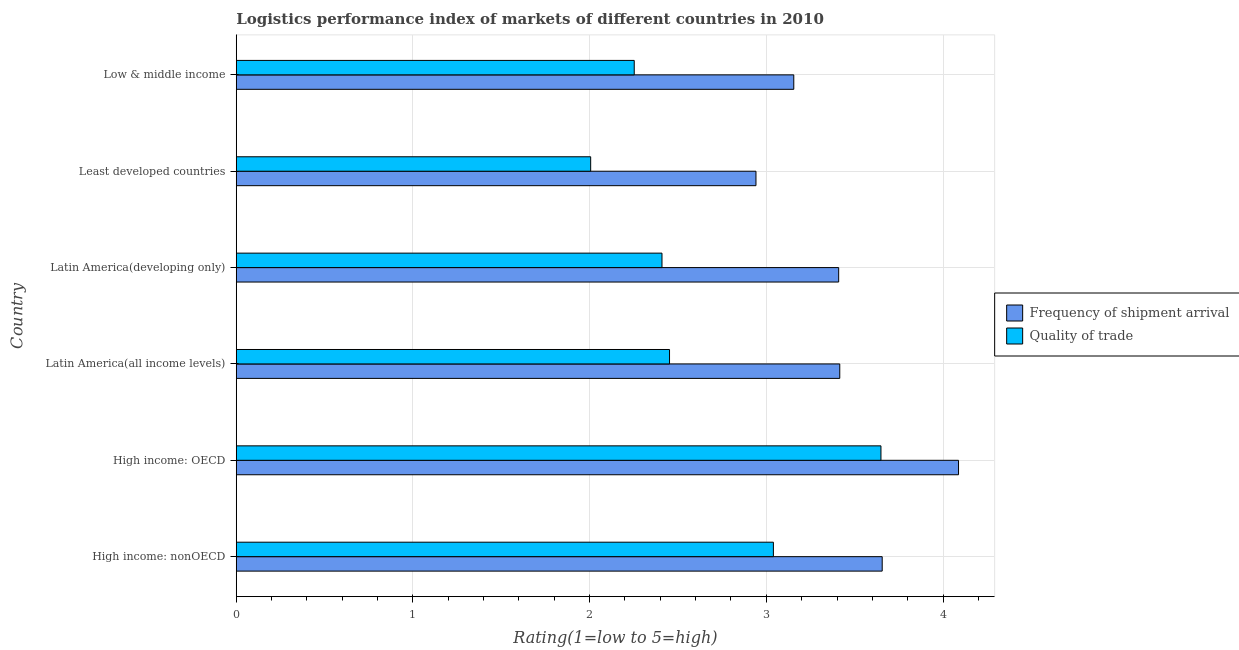How many different coloured bars are there?
Offer a very short reply. 2. How many groups of bars are there?
Your answer should be very brief. 6. What is the label of the 2nd group of bars from the top?
Provide a succinct answer. Least developed countries. In how many cases, is the number of bars for a given country not equal to the number of legend labels?
Keep it short and to the point. 0. What is the lpi quality of trade in Latin America(all income levels)?
Give a very brief answer. 2.45. Across all countries, what is the maximum lpi quality of trade?
Make the answer very short. 3.65. Across all countries, what is the minimum lpi quality of trade?
Provide a succinct answer. 2.01. In which country was the lpi quality of trade maximum?
Ensure brevity in your answer.  High income: OECD. In which country was the lpi quality of trade minimum?
Offer a terse response. Least developed countries. What is the total lpi quality of trade in the graph?
Keep it short and to the point. 15.81. What is the difference between the lpi quality of trade in High income: nonOECD and that in Latin America(all income levels)?
Make the answer very short. 0.59. What is the difference between the lpi quality of trade in Low & middle income and the lpi of frequency of shipment arrival in Latin America(all income levels)?
Your response must be concise. -1.16. What is the average lpi of frequency of shipment arrival per country?
Your answer should be compact. 3.44. What is the difference between the lpi of frequency of shipment arrival and lpi quality of trade in High income: nonOECD?
Keep it short and to the point. 0.62. What is the ratio of the lpi quality of trade in High income: nonOECD to that in Least developed countries?
Your answer should be very brief. 1.52. Is the difference between the lpi of frequency of shipment arrival in Latin America(all income levels) and Low & middle income greater than the difference between the lpi quality of trade in Latin America(all income levels) and Low & middle income?
Provide a short and direct response. Yes. What is the difference between the highest and the second highest lpi of frequency of shipment arrival?
Give a very brief answer. 0.43. What is the difference between the highest and the lowest lpi of frequency of shipment arrival?
Your response must be concise. 1.15. In how many countries, is the lpi quality of trade greater than the average lpi quality of trade taken over all countries?
Your response must be concise. 2. What does the 1st bar from the top in Latin America(developing only) represents?
Ensure brevity in your answer.  Quality of trade. What does the 1st bar from the bottom in Low & middle income represents?
Your response must be concise. Frequency of shipment arrival. How many countries are there in the graph?
Keep it short and to the point. 6. What is the difference between two consecutive major ticks on the X-axis?
Your answer should be very brief. 1. Are the values on the major ticks of X-axis written in scientific E-notation?
Your answer should be very brief. No. Does the graph contain any zero values?
Give a very brief answer. No. Where does the legend appear in the graph?
Your answer should be compact. Center right. How many legend labels are there?
Your answer should be compact. 2. How are the legend labels stacked?
Your answer should be compact. Vertical. What is the title of the graph?
Provide a succinct answer. Logistics performance index of markets of different countries in 2010. Does "Taxes on exports" appear as one of the legend labels in the graph?
Offer a terse response. No. What is the label or title of the X-axis?
Provide a succinct answer. Rating(1=low to 5=high). What is the label or title of the Y-axis?
Provide a succinct answer. Country. What is the Rating(1=low to 5=high) of Frequency of shipment arrival in High income: nonOECD?
Give a very brief answer. 3.66. What is the Rating(1=low to 5=high) of Quality of trade in High income: nonOECD?
Offer a terse response. 3.04. What is the Rating(1=low to 5=high) in Frequency of shipment arrival in High income: OECD?
Your answer should be compact. 4.09. What is the Rating(1=low to 5=high) of Quality of trade in High income: OECD?
Offer a terse response. 3.65. What is the Rating(1=low to 5=high) in Frequency of shipment arrival in Latin America(all income levels)?
Offer a terse response. 3.42. What is the Rating(1=low to 5=high) in Quality of trade in Latin America(all income levels)?
Make the answer very short. 2.45. What is the Rating(1=low to 5=high) in Frequency of shipment arrival in Latin America(developing only)?
Make the answer very short. 3.41. What is the Rating(1=low to 5=high) of Quality of trade in Latin America(developing only)?
Offer a very short reply. 2.41. What is the Rating(1=low to 5=high) of Frequency of shipment arrival in Least developed countries?
Your answer should be very brief. 2.94. What is the Rating(1=low to 5=high) in Quality of trade in Least developed countries?
Keep it short and to the point. 2.01. What is the Rating(1=low to 5=high) in Frequency of shipment arrival in Low & middle income?
Provide a succinct answer. 3.16. What is the Rating(1=low to 5=high) in Quality of trade in Low & middle income?
Offer a very short reply. 2.25. Across all countries, what is the maximum Rating(1=low to 5=high) in Frequency of shipment arrival?
Make the answer very short. 4.09. Across all countries, what is the maximum Rating(1=low to 5=high) of Quality of trade?
Offer a terse response. 3.65. Across all countries, what is the minimum Rating(1=low to 5=high) of Frequency of shipment arrival?
Give a very brief answer. 2.94. Across all countries, what is the minimum Rating(1=low to 5=high) in Quality of trade?
Your response must be concise. 2.01. What is the total Rating(1=low to 5=high) of Frequency of shipment arrival in the graph?
Provide a succinct answer. 20.67. What is the total Rating(1=low to 5=high) of Quality of trade in the graph?
Give a very brief answer. 15.81. What is the difference between the Rating(1=low to 5=high) of Frequency of shipment arrival in High income: nonOECD and that in High income: OECD?
Your answer should be very brief. -0.43. What is the difference between the Rating(1=low to 5=high) of Quality of trade in High income: nonOECD and that in High income: OECD?
Offer a very short reply. -0.61. What is the difference between the Rating(1=low to 5=high) in Frequency of shipment arrival in High income: nonOECD and that in Latin America(all income levels)?
Provide a short and direct response. 0.24. What is the difference between the Rating(1=low to 5=high) in Quality of trade in High income: nonOECD and that in Latin America(all income levels)?
Give a very brief answer. 0.59. What is the difference between the Rating(1=low to 5=high) in Frequency of shipment arrival in High income: nonOECD and that in Latin America(developing only)?
Your answer should be very brief. 0.25. What is the difference between the Rating(1=low to 5=high) of Quality of trade in High income: nonOECD and that in Latin America(developing only)?
Give a very brief answer. 0.63. What is the difference between the Rating(1=low to 5=high) of Frequency of shipment arrival in High income: nonOECD and that in Least developed countries?
Make the answer very short. 0.71. What is the difference between the Rating(1=low to 5=high) of Quality of trade in High income: nonOECD and that in Least developed countries?
Your response must be concise. 1.03. What is the difference between the Rating(1=low to 5=high) in Frequency of shipment arrival in High income: nonOECD and that in Low & middle income?
Ensure brevity in your answer.  0.5. What is the difference between the Rating(1=low to 5=high) in Quality of trade in High income: nonOECD and that in Low & middle income?
Your response must be concise. 0.79. What is the difference between the Rating(1=low to 5=high) in Frequency of shipment arrival in High income: OECD and that in Latin America(all income levels)?
Make the answer very short. 0.67. What is the difference between the Rating(1=low to 5=high) of Quality of trade in High income: OECD and that in Latin America(all income levels)?
Provide a short and direct response. 1.2. What is the difference between the Rating(1=low to 5=high) of Frequency of shipment arrival in High income: OECD and that in Latin America(developing only)?
Give a very brief answer. 0.68. What is the difference between the Rating(1=low to 5=high) in Quality of trade in High income: OECD and that in Latin America(developing only)?
Provide a succinct answer. 1.24. What is the difference between the Rating(1=low to 5=high) of Frequency of shipment arrival in High income: OECD and that in Least developed countries?
Your response must be concise. 1.15. What is the difference between the Rating(1=low to 5=high) of Quality of trade in High income: OECD and that in Least developed countries?
Offer a terse response. 1.64. What is the difference between the Rating(1=low to 5=high) in Frequency of shipment arrival in High income: OECD and that in Low & middle income?
Your response must be concise. 0.93. What is the difference between the Rating(1=low to 5=high) of Quality of trade in High income: OECD and that in Low & middle income?
Provide a short and direct response. 1.4. What is the difference between the Rating(1=low to 5=high) in Frequency of shipment arrival in Latin America(all income levels) and that in Latin America(developing only)?
Your answer should be compact. 0.01. What is the difference between the Rating(1=low to 5=high) of Quality of trade in Latin America(all income levels) and that in Latin America(developing only)?
Give a very brief answer. 0.04. What is the difference between the Rating(1=low to 5=high) of Frequency of shipment arrival in Latin America(all income levels) and that in Least developed countries?
Give a very brief answer. 0.47. What is the difference between the Rating(1=low to 5=high) in Quality of trade in Latin America(all income levels) and that in Least developed countries?
Your response must be concise. 0.45. What is the difference between the Rating(1=low to 5=high) in Frequency of shipment arrival in Latin America(all income levels) and that in Low & middle income?
Keep it short and to the point. 0.26. What is the difference between the Rating(1=low to 5=high) in Quality of trade in Latin America(all income levels) and that in Low & middle income?
Offer a terse response. 0.2. What is the difference between the Rating(1=low to 5=high) of Frequency of shipment arrival in Latin America(developing only) and that in Least developed countries?
Provide a succinct answer. 0.47. What is the difference between the Rating(1=low to 5=high) in Quality of trade in Latin America(developing only) and that in Least developed countries?
Provide a short and direct response. 0.4. What is the difference between the Rating(1=low to 5=high) in Frequency of shipment arrival in Latin America(developing only) and that in Low & middle income?
Your response must be concise. 0.25. What is the difference between the Rating(1=low to 5=high) of Quality of trade in Latin America(developing only) and that in Low & middle income?
Ensure brevity in your answer.  0.16. What is the difference between the Rating(1=low to 5=high) of Frequency of shipment arrival in Least developed countries and that in Low & middle income?
Provide a short and direct response. -0.21. What is the difference between the Rating(1=low to 5=high) of Quality of trade in Least developed countries and that in Low & middle income?
Make the answer very short. -0.25. What is the difference between the Rating(1=low to 5=high) in Frequency of shipment arrival in High income: nonOECD and the Rating(1=low to 5=high) in Quality of trade in High income: OECD?
Your response must be concise. 0.01. What is the difference between the Rating(1=low to 5=high) of Frequency of shipment arrival in High income: nonOECD and the Rating(1=low to 5=high) of Quality of trade in Latin America(all income levels)?
Your answer should be compact. 1.2. What is the difference between the Rating(1=low to 5=high) of Frequency of shipment arrival in High income: nonOECD and the Rating(1=low to 5=high) of Quality of trade in Latin America(developing only)?
Your answer should be very brief. 1.25. What is the difference between the Rating(1=low to 5=high) in Frequency of shipment arrival in High income: nonOECD and the Rating(1=low to 5=high) in Quality of trade in Least developed countries?
Your answer should be very brief. 1.65. What is the difference between the Rating(1=low to 5=high) in Frequency of shipment arrival in High income: nonOECD and the Rating(1=low to 5=high) in Quality of trade in Low & middle income?
Provide a succinct answer. 1.4. What is the difference between the Rating(1=low to 5=high) in Frequency of shipment arrival in High income: OECD and the Rating(1=low to 5=high) in Quality of trade in Latin America(all income levels)?
Make the answer very short. 1.64. What is the difference between the Rating(1=low to 5=high) in Frequency of shipment arrival in High income: OECD and the Rating(1=low to 5=high) in Quality of trade in Latin America(developing only)?
Provide a short and direct response. 1.68. What is the difference between the Rating(1=low to 5=high) of Frequency of shipment arrival in High income: OECD and the Rating(1=low to 5=high) of Quality of trade in Least developed countries?
Offer a very short reply. 2.08. What is the difference between the Rating(1=low to 5=high) of Frequency of shipment arrival in High income: OECD and the Rating(1=low to 5=high) of Quality of trade in Low & middle income?
Offer a very short reply. 1.84. What is the difference between the Rating(1=low to 5=high) in Frequency of shipment arrival in Latin America(all income levels) and the Rating(1=low to 5=high) in Quality of trade in Latin America(developing only)?
Provide a succinct answer. 1.01. What is the difference between the Rating(1=low to 5=high) of Frequency of shipment arrival in Latin America(all income levels) and the Rating(1=low to 5=high) of Quality of trade in Least developed countries?
Offer a terse response. 1.41. What is the difference between the Rating(1=low to 5=high) of Frequency of shipment arrival in Latin America(all income levels) and the Rating(1=low to 5=high) of Quality of trade in Low & middle income?
Your response must be concise. 1.16. What is the difference between the Rating(1=low to 5=high) in Frequency of shipment arrival in Latin America(developing only) and the Rating(1=low to 5=high) in Quality of trade in Least developed countries?
Offer a very short reply. 1.4. What is the difference between the Rating(1=low to 5=high) of Frequency of shipment arrival in Latin America(developing only) and the Rating(1=low to 5=high) of Quality of trade in Low & middle income?
Offer a terse response. 1.16. What is the difference between the Rating(1=low to 5=high) of Frequency of shipment arrival in Least developed countries and the Rating(1=low to 5=high) of Quality of trade in Low & middle income?
Offer a very short reply. 0.69. What is the average Rating(1=low to 5=high) in Frequency of shipment arrival per country?
Provide a short and direct response. 3.44. What is the average Rating(1=low to 5=high) in Quality of trade per country?
Provide a short and direct response. 2.63. What is the difference between the Rating(1=low to 5=high) of Frequency of shipment arrival and Rating(1=low to 5=high) of Quality of trade in High income: nonOECD?
Keep it short and to the point. 0.62. What is the difference between the Rating(1=low to 5=high) in Frequency of shipment arrival and Rating(1=low to 5=high) in Quality of trade in High income: OECD?
Your answer should be very brief. 0.44. What is the difference between the Rating(1=low to 5=high) in Frequency of shipment arrival and Rating(1=low to 5=high) in Quality of trade in Latin America(all income levels)?
Keep it short and to the point. 0.96. What is the difference between the Rating(1=low to 5=high) of Frequency of shipment arrival and Rating(1=low to 5=high) of Quality of trade in Least developed countries?
Keep it short and to the point. 0.94. What is the difference between the Rating(1=low to 5=high) in Frequency of shipment arrival and Rating(1=low to 5=high) in Quality of trade in Low & middle income?
Your answer should be compact. 0.9. What is the ratio of the Rating(1=low to 5=high) of Frequency of shipment arrival in High income: nonOECD to that in High income: OECD?
Your answer should be very brief. 0.89. What is the ratio of the Rating(1=low to 5=high) in Quality of trade in High income: nonOECD to that in High income: OECD?
Your answer should be very brief. 0.83. What is the ratio of the Rating(1=low to 5=high) in Frequency of shipment arrival in High income: nonOECD to that in Latin America(all income levels)?
Provide a short and direct response. 1.07. What is the ratio of the Rating(1=low to 5=high) of Quality of trade in High income: nonOECD to that in Latin America(all income levels)?
Provide a succinct answer. 1.24. What is the ratio of the Rating(1=low to 5=high) of Frequency of shipment arrival in High income: nonOECD to that in Latin America(developing only)?
Your answer should be compact. 1.07. What is the ratio of the Rating(1=low to 5=high) of Quality of trade in High income: nonOECD to that in Latin America(developing only)?
Keep it short and to the point. 1.26. What is the ratio of the Rating(1=low to 5=high) of Frequency of shipment arrival in High income: nonOECD to that in Least developed countries?
Offer a terse response. 1.24. What is the ratio of the Rating(1=low to 5=high) of Quality of trade in High income: nonOECD to that in Least developed countries?
Ensure brevity in your answer.  1.52. What is the ratio of the Rating(1=low to 5=high) in Frequency of shipment arrival in High income: nonOECD to that in Low & middle income?
Offer a very short reply. 1.16. What is the ratio of the Rating(1=low to 5=high) of Quality of trade in High income: nonOECD to that in Low & middle income?
Provide a short and direct response. 1.35. What is the ratio of the Rating(1=low to 5=high) of Frequency of shipment arrival in High income: OECD to that in Latin America(all income levels)?
Your answer should be very brief. 1.2. What is the ratio of the Rating(1=low to 5=high) in Quality of trade in High income: OECD to that in Latin America(all income levels)?
Offer a very short reply. 1.49. What is the ratio of the Rating(1=low to 5=high) of Frequency of shipment arrival in High income: OECD to that in Latin America(developing only)?
Offer a terse response. 1.2. What is the ratio of the Rating(1=low to 5=high) in Quality of trade in High income: OECD to that in Latin America(developing only)?
Give a very brief answer. 1.51. What is the ratio of the Rating(1=low to 5=high) of Frequency of shipment arrival in High income: OECD to that in Least developed countries?
Your answer should be compact. 1.39. What is the ratio of the Rating(1=low to 5=high) of Quality of trade in High income: OECD to that in Least developed countries?
Keep it short and to the point. 1.82. What is the ratio of the Rating(1=low to 5=high) of Frequency of shipment arrival in High income: OECD to that in Low & middle income?
Keep it short and to the point. 1.3. What is the ratio of the Rating(1=low to 5=high) in Quality of trade in High income: OECD to that in Low & middle income?
Give a very brief answer. 1.62. What is the ratio of the Rating(1=low to 5=high) of Frequency of shipment arrival in Latin America(all income levels) to that in Latin America(developing only)?
Provide a succinct answer. 1. What is the ratio of the Rating(1=low to 5=high) of Quality of trade in Latin America(all income levels) to that in Latin America(developing only)?
Provide a succinct answer. 1.02. What is the ratio of the Rating(1=low to 5=high) in Frequency of shipment arrival in Latin America(all income levels) to that in Least developed countries?
Offer a very short reply. 1.16. What is the ratio of the Rating(1=low to 5=high) in Quality of trade in Latin America(all income levels) to that in Least developed countries?
Your response must be concise. 1.22. What is the ratio of the Rating(1=low to 5=high) in Frequency of shipment arrival in Latin America(all income levels) to that in Low & middle income?
Keep it short and to the point. 1.08. What is the ratio of the Rating(1=low to 5=high) in Quality of trade in Latin America(all income levels) to that in Low & middle income?
Your response must be concise. 1.09. What is the ratio of the Rating(1=low to 5=high) of Frequency of shipment arrival in Latin America(developing only) to that in Least developed countries?
Provide a short and direct response. 1.16. What is the ratio of the Rating(1=low to 5=high) of Quality of trade in Latin America(developing only) to that in Least developed countries?
Give a very brief answer. 1.2. What is the ratio of the Rating(1=low to 5=high) in Frequency of shipment arrival in Latin America(developing only) to that in Low & middle income?
Your response must be concise. 1.08. What is the ratio of the Rating(1=low to 5=high) in Quality of trade in Latin America(developing only) to that in Low & middle income?
Your answer should be very brief. 1.07. What is the ratio of the Rating(1=low to 5=high) in Frequency of shipment arrival in Least developed countries to that in Low & middle income?
Your answer should be compact. 0.93. What is the ratio of the Rating(1=low to 5=high) in Quality of trade in Least developed countries to that in Low & middle income?
Offer a very short reply. 0.89. What is the difference between the highest and the second highest Rating(1=low to 5=high) of Frequency of shipment arrival?
Your answer should be very brief. 0.43. What is the difference between the highest and the second highest Rating(1=low to 5=high) in Quality of trade?
Ensure brevity in your answer.  0.61. What is the difference between the highest and the lowest Rating(1=low to 5=high) in Frequency of shipment arrival?
Keep it short and to the point. 1.15. What is the difference between the highest and the lowest Rating(1=low to 5=high) in Quality of trade?
Ensure brevity in your answer.  1.64. 